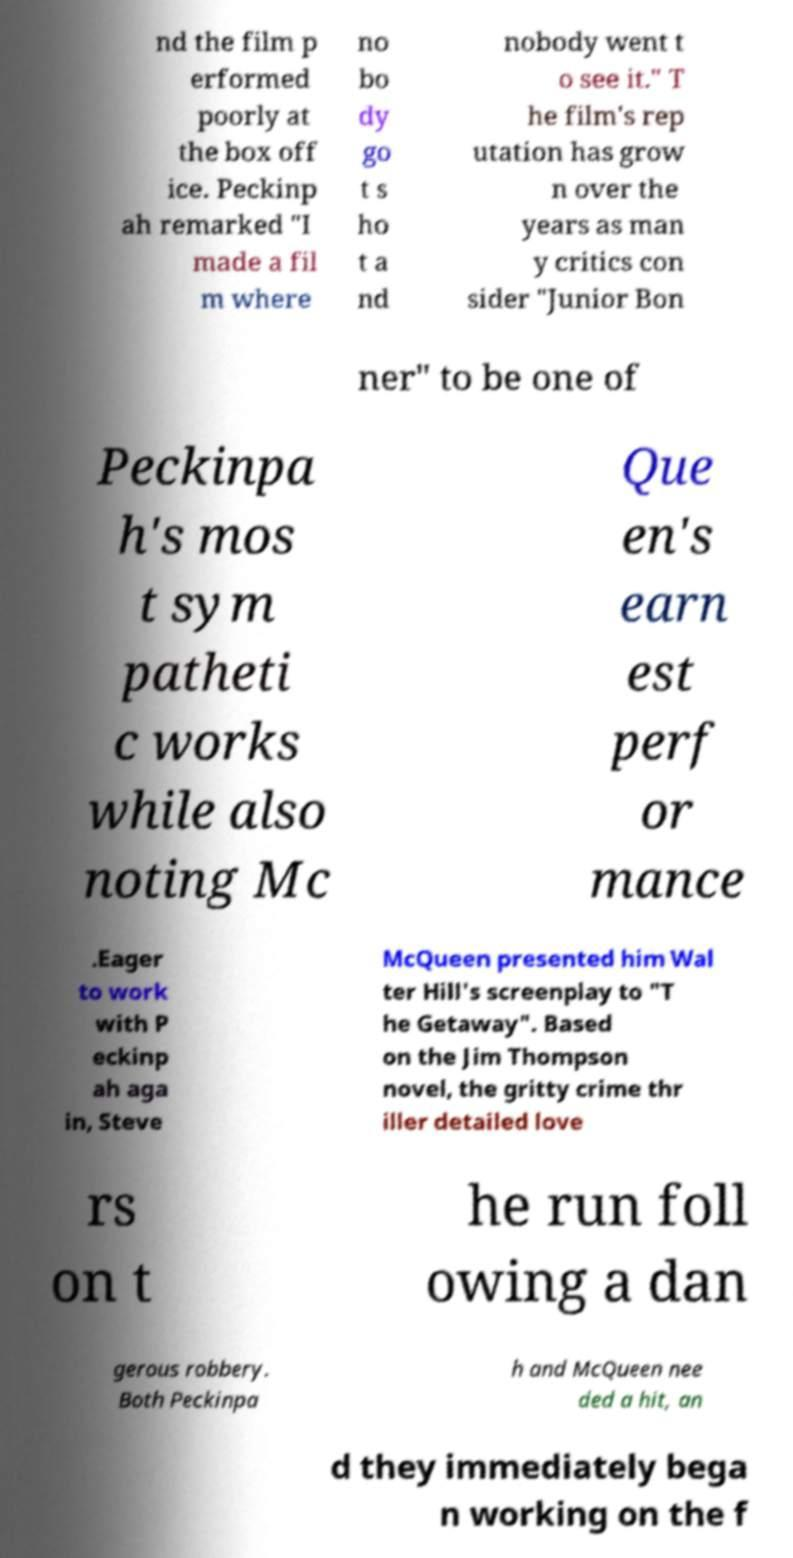I need the written content from this picture converted into text. Can you do that? nd the film p erformed poorly at the box off ice. Peckinp ah remarked "I made a fil m where no bo dy go t s ho t a nd nobody went t o see it." T he film's rep utation has grow n over the years as man y critics con sider "Junior Bon ner" to be one of Peckinpa h's mos t sym patheti c works while also noting Mc Que en's earn est perf or mance .Eager to work with P eckinp ah aga in, Steve McQueen presented him Wal ter Hill's screenplay to "T he Getaway". Based on the Jim Thompson novel, the gritty crime thr iller detailed love rs on t he run foll owing a dan gerous robbery. Both Peckinpa h and McQueen nee ded a hit, an d they immediately bega n working on the f 